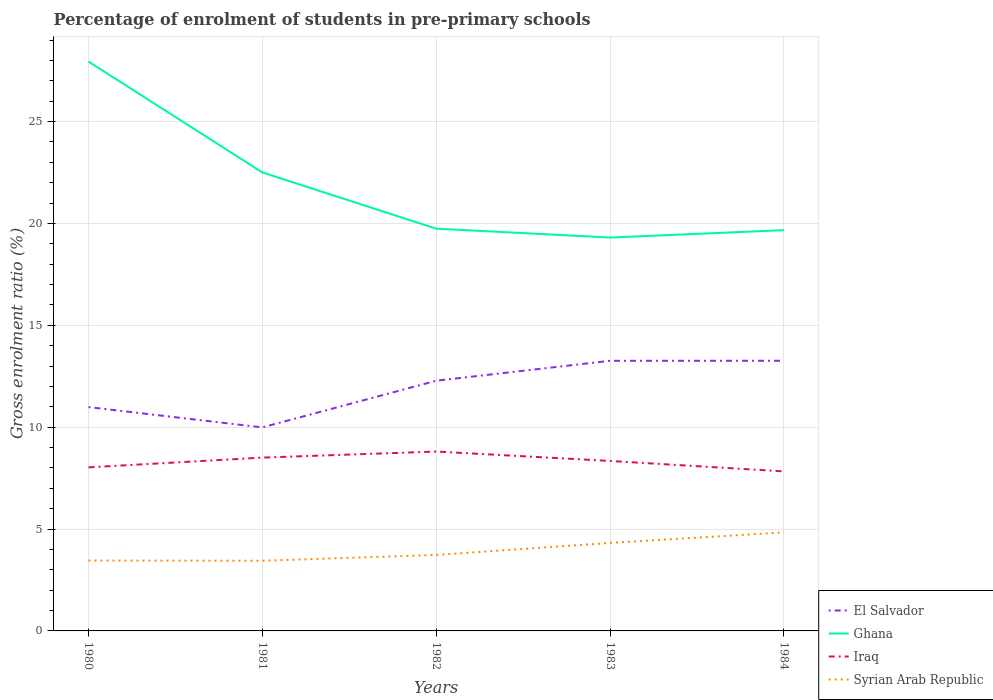How many different coloured lines are there?
Your answer should be very brief. 4. Across all years, what is the maximum percentage of students enrolled in pre-primary schools in Syrian Arab Republic?
Offer a very short reply. 3.44. What is the total percentage of students enrolled in pre-primary schools in Ghana in the graph?
Offer a very short reply. 2.76. What is the difference between the highest and the second highest percentage of students enrolled in pre-primary schools in Iraq?
Offer a very short reply. 0.97. What is the difference between the highest and the lowest percentage of students enrolled in pre-primary schools in Ghana?
Your answer should be very brief. 2. How many lines are there?
Your answer should be very brief. 4. How many years are there in the graph?
Your answer should be compact. 5. What is the difference between two consecutive major ticks on the Y-axis?
Keep it short and to the point. 5. Are the values on the major ticks of Y-axis written in scientific E-notation?
Your answer should be very brief. No. Does the graph contain any zero values?
Make the answer very short. No. Where does the legend appear in the graph?
Provide a succinct answer. Bottom right. How are the legend labels stacked?
Give a very brief answer. Vertical. What is the title of the graph?
Your response must be concise. Percentage of enrolment of students in pre-primary schools. Does "Serbia" appear as one of the legend labels in the graph?
Make the answer very short. No. What is the label or title of the X-axis?
Make the answer very short. Years. What is the Gross enrolment ratio (%) in El Salvador in 1980?
Provide a short and direct response. 10.99. What is the Gross enrolment ratio (%) of Ghana in 1980?
Provide a succinct answer. 27.94. What is the Gross enrolment ratio (%) of Iraq in 1980?
Your answer should be very brief. 8.03. What is the Gross enrolment ratio (%) in Syrian Arab Republic in 1980?
Make the answer very short. 3.45. What is the Gross enrolment ratio (%) in El Salvador in 1981?
Your answer should be compact. 9.99. What is the Gross enrolment ratio (%) of Ghana in 1981?
Give a very brief answer. 22.5. What is the Gross enrolment ratio (%) in Iraq in 1981?
Ensure brevity in your answer.  8.51. What is the Gross enrolment ratio (%) in Syrian Arab Republic in 1981?
Offer a very short reply. 3.44. What is the Gross enrolment ratio (%) of El Salvador in 1982?
Ensure brevity in your answer.  12.28. What is the Gross enrolment ratio (%) in Ghana in 1982?
Your answer should be compact. 19.74. What is the Gross enrolment ratio (%) in Iraq in 1982?
Offer a terse response. 8.8. What is the Gross enrolment ratio (%) of Syrian Arab Republic in 1982?
Your response must be concise. 3.73. What is the Gross enrolment ratio (%) of El Salvador in 1983?
Offer a terse response. 13.26. What is the Gross enrolment ratio (%) in Ghana in 1983?
Offer a very short reply. 19.31. What is the Gross enrolment ratio (%) of Iraq in 1983?
Make the answer very short. 8.34. What is the Gross enrolment ratio (%) of Syrian Arab Republic in 1983?
Your response must be concise. 4.32. What is the Gross enrolment ratio (%) of El Salvador in 1984?
Give a very brief answer. 13.26. What is the Gross enrolment ratio (%) of Ghana in 1984?
Provide a short and direct response. 19.67. What is the Gross enrolment ratio (%) in Iraq in 1984?
Make the answer very short. 7.83. What is the Gross enrolment ratio (%) in Syrian Arab Republic in 1984?
Provide a short and direct response. 4.84. Across all years, what is the maximum Gross enrolment ratio (%) of El Salvador?
Provide a short and direct response. 13.26. Across all years, what is the maximum Gross enrolment ratio (%) of Ghana?
Provide a short and direct response. 27.94. Across all years, what is the maximum Gross enrolment ratio (%) in Iraq?
Offer a very short reply. 8.8. Across all years, what is the maximum Gross enrolment ratio (%) in Syrian Arab Republic?
Your response must be concise. 4.84. Across all years, what is the minimum Gross enrolment ratio (%) in El Salvador?
Your answer should be very brief. 9.99. Across all years, what is the minimum Gross enrolment ratio (%) in Ghana?
Ensure brevity in your answer.  19.31. Across all years, what is the minimum Gross enrolment ratio (%) of Iraq?
Give a very brief answer. 7.83. Across all years, what is the minimum Gross enrolment ratio (%) in Syrian Arab Republic?
Your answer should be compact. 3.44. What is the total Gross enrolment ratio (%) in El Salvador in the graph?
Your answer should be compact. 59.77. What is the total Gross enrolment ratio (%) in Ghana in the graph?
Provide a succinct answer. 109.16. What is the total Gross enrolment ratio (%) in Iraq in the graph?
Your response must be concise. 41.51. What is the total Gross enrolment ratio (%) in Syrian Arab Republic in the graph?
Give a very brief answer. 19.78. What is the difference between the Gross enrolment ratio (%) in Ghana in 1980 and that in 1981?
Provide a succinct answer. 5.44. What is the difference between the Gross enrolment ratio (%) in Iraq in 1980 and that in 1981?
Give a very brief answer. -0.48. What is the difference between the Gross enrolment ratio (%) in Syrian Arab Republic in 1980 and that in 1981?
Keep it short and to the point. 0.01. What is the difference between the Gross enrolment ratio (%) of El Salvador in 1980 and that in 1982?
Provide a succinct answer. -1.29. What is the difference between the Gross enrolment ratio (%) in Ghana in 1980 and that in 1982?
Your response must be concise. 8.2. What is the difference between the Gross enrolment ratio (%) of Iraq in 1980 and that in 1982?
Your response must be concise. -0.78. What is the difference between the Gross enrolment ratio (%) in Syrian Arab Republic in 1980 and that in 1982?
Provide a short and direct response. -0.28. What is the difference between the Gross enrolment ratio (%) of El Salvador in 1980 and that in 1983?
Ensure brevity in your answer.  -2.27. What is the difference between the Gross enrolment ratio (%) in Ghana in 1980 and that in 1983?
Your answer should be very brief. 8.64. What is the difference between the Gross enrolment ratio (%) of Iraq in 1980 and that in 1983?
Offer a very short reply. -0.31. What is the difference between the Gross enrolment ratio (%) in Syrian Arab Republic in 1980 and that in 1983?
Offer a very short reply. -0.87. What is the difference between the Gross enrolment ratio (%) of El Salvador in 1980 and that in 1984?
Offer a very short reply. -2.27. What is the difference between the Gross enrolment ratio (%) of Ghana in 1980 and that in 1984?
Keep it short and to the point. 8.27. What is the difference between the Gross enrolment ratio (%) of Iraq in 1980 and that in 1984?
Your response must be concise. 0.2. What is the difference between the Gross enrolment ratio (%) in Syrian Arab Republic in 1980 and that in 1984?
Your answer should be compact. -1.38. What is the difference between the Gross enrolment ratio (%) of El Salvador in 1981 and that in 1982?
Make the answer very short. -2.29. What is the difference between the Gross enrolment ratio (%) in Ghana in 1981 and that in 1982?
Give a very brief answer. 2.76. What is the difference between the Gross enrolment ratio (%) of Iraq in 1981 and that in 1982?
Give a very brief answer. -0.3. What is the difference between the Gross enrolment ratio (%) in Syrian Arab Republic in 1981 and that in 1982?
Offer a terse response. -0.28. What is the difference between the Gross enrolment ratio (%) of El Salvador in 1981 and that in 1983?
Provide a short and direct response. -3.27. What is the difference between the Gross enrolment ratio (%) of Ghana in 1981 and that in 1983?
Your answer should be very brief. 3.2. What is the difference between the Gross enrolment ratio (%) in Iraq in 1981 and that in 1983?
Provide a succinct answer. 0.16. What is the difference between the Gross enrolment ratio (%) of Syrian Arab Republic in 1981 and that in 1983?
Offer a terse response. -0.88. What is the difference between the Gross enrolment ratio (%) in El Salvador in 1981 and that in 1984?
Ensure brevity in your answer.  -3.27. What is the difference between the Gross enrolment ratio (%) of Ghana in 1981 and that in 1984?
Keep it short and to the point. 2.83. What is the difference between the Gross enrolment ratio (%) in Iraq in 1981 and that in 1984?
Provide a succinct answer. 0.68. What is the difference between the Gross enrolment ratio (%) of Syrian Arab Republic in 1981 and that in 1984?
Provide a succinct answer. -1.39. What is the difference between the Gross enrolment ratio (%) in El Salvador in 1982 and that in 1983?
Give a very brief answer. -0.98. What is the difference between the Gross enrolment ratio (%) in Ghana in 1982 and that in 1983?
Ensure brevity in your answer.  0.44. What is the difference between the Gross enrolment ratio (%) in Iraq in 1982 and that in 1983?
Your answer should be compact. 0.46. What is the difference between the Gross enrolment ratio (%) of Syrian Arab Republic in 1982 and that in 1983?
Your answer should be compact. -0.59. What is the difference between the Gross enrolment ratio (%) in El Salvador in 1982 and that in 1984?
Keep it short and to the point. -0.98. What is the difference between the Gross enrolment ratio (%) of Ghana in 1982 and that in 1984?
Offer a very short reply. 0.07. What is the difference between the Gross enrolment ratio (%) of Iraq in 1982 and that in 1984?
Your response must be concise. 0.97. What is the difference between the Gross enrolment ratio (%) of Syrian Arab Republic in 1982 and that in 1984?
Give a very brief answer. -1.11. What is the difference between the Gross enrolment ratio (%) of El Salvador in 1983 and that in 1984?
Your answer should be very brief. -0. What is the difference between the Gross enrolment ratio (%) in Ghana in 1983 and that in 1984?
Your response must be concise. -0.36. What is the difference between the Gross enrolment ratio (%) in Iraq in 1983 and that in 1984?
Your response must be concise. 0.51. What is the difference between the Gross enrolment ratio (%) of Syrian Arab Republic in 1983 and that in 1984?
Ensure brevity in your answer.  -0.52. What is the difference between the Gross enrolment ratio (%) of El Salvador in 1980 and the Gross enrolment ratio (%) of Ghana in 1981?
Offer a very short reply. -11.52. What is the difference between the Gross enrolment ratio (%) of El Salvador in 1980 and the Gross enrolment ratio (%) of Iraq in 1981?
Ensure brevity in your answer.  2.48. What is the difference between the Gross enrolment ratio (%) in El Salvador in 1980 and the Gross enrolment ratio (%) in Syrian Arab Republic in 1981?
Offer a terse response. 7.54. What is the difference between the Gross enrolment ratio (%) of Ghana in 1980 and the Gross enrolment ratio (%) of Iraq in 1981?
Offer a very short reply. 19.44. What is the difference between the Gross enrolment ratio (%) of Ghana in 1980 and the Gross enrolment ratio (%) of Syrian Arab Republic in 1981?
Keep it short and to the point. 24.5. What is the difference between the Gross enrolment ratio (%) of Iraq in 1980 and the Gross enrolment ratio (%) of Syrian Arab Republic in 1981?
Offer a very short reply. 4.58. What is the difference between the Gross enrolment ratio (%) in El Salvador in 1980 and the Gross enrolment ratio (%) in Ghana in 1982?
Offer a terse response. -8.76. What is the difference between the Gross enrolment ratio (%) of El Salvador in 1980 and the Gross enrolment ratio (%) of Iraq in 1982?
Offer a very short reply. 2.18. What is the difference between the Gross enrolment ratio (%) in El Salvador in 1980 and the Gross enrolment ratio (%) in Syrian Arab Republic in 1982?
Your answer should be compact. 7.26. What is the difference between the Gross enrolment ratio (%) in Ghana in 1980 and the Gross enrolment ratio (%) in Iraq in 1982?
Your response must be concise. 19.14. What is the difference between the Gross enrolment ratio (%) of Ghana in 1980 and the Gross enrolment ratio (%) of Syrian Arab Republic in 1982?
Keep it short and to the point. 24.22. What is the difference between the Gross enrolment ratio (%) of Iraq in 1980 and the Gross enrolment ratio (%) of Syrian Arab Republic in 1982?
Give a very brief answer. 4.3. What is the difference between the Gross enrolment ratio (%) in El Salvador in 1980 and the Gross enrolment ratio (%) in Ghana in 1983?
Your answer should be compact. -8.32. What is the difference between the Gross enrolment ratio (%) in El Salvador in 1980 and the Gross enrolment ratio (%) in Iraq in 1983?
Make the answer very short. 2.64. What is the difference between the Gross enrolment ratio (%) of El Salvador in 1980 and the Gross enrolment ratio (%) of Syrian Arab Republic in 1983?
Your answer should be very brief. 6.67. What is the difference between the Gross enrolment ratio (%) of Ghana in 1980 and the Gross enrolment ratio (%) of Iraq in 1983?
Offer a very short reply. 19.6. What is the difference between the Gross enrolment ratio (%) of Ghana in 1980 and the Gross enrolment ratio (%) of Syrian Arab Republic in 1983?
Make the answer very short. 23.62. What is the difference between the Gross enrolment ratio (%) in Iraq in 1980 and the Gross enrolment ratio (%) in Syrian Arab Republic in 1983?
Your answer should be very brief. 3.71. What is the difference between the Gross enrolment ratio (%) of El Salvador in 1980 and the Gross enrolment ratio (%) of Ghana in 1984?
Offer a very short reply. -8.68. What is the difference between the Gross enrolment ratio (%) in El Salvador in 1980 and the Gross enrolment ratio (%) in Iraq in 1984?
Offer a terse response. 3.16. What is the difference between the Gross enrolment ratio (%) in El Salvador in 1980 and the Gross enrolment ratio (%) in Syrian Arab Republic in 1984?
Provide a succinct answer. 6.15. What is the difference between the Gross enrolment ratio (%) of Ghana in 1980 and the Gross enrolment ratio (%) of Iraq in 1984?
Offer a terse response. 20.11. What is the difference between the Gross enrolment ratio (%) in Ghana in 1980 and the Gross enrolment ratio (%) in Syrian Arab Republic in 1984?
Give a very brief answer. 23.11. What is the difference between the Gross enrolment ratio (%) of Iraq in 1980 and the Gross enrolment ratio (%) of Syrian Arab Republic in 1984?
Provide a short and direct response. 3.19. What is the difference between the Gross enrolment ratio (%) in El Salvador in 1981 and the Gross enrolment ratio (%) in Ghana in 1982?
Keep it short and to the point. -9.75. What is the difference between the Gross enrolment ratio (%) in El Salvador in 1981 and the Gross enrolment ratio (%) in Iraq in 1982?
Ensure brevity in your answer.  1.19. What is the difference between the Gross enrolment ratio (%) in El Salvador in 1981 and the Gross enrolment ratio (%) in Syrian Arab Republic in 1982?
Ensure brevity in your answer.  6.26. What is the difference between the Gross enrolment ratio (%) of Ghana in 1981 and the Gross enrolment ratio (%) of Iraq in 1982?
Your response must be concise. 13.7. What is the difference between the Gross enrolment ratio (%) in Ghana in 1981 and the Gross enrolment ratio (%) in Syrian Arab Republic in 1982?
Provide a succinct answer. 18.77. What is the difference between the Gross enrolment ratio (%) of Iraq in 1981 and the Gross enrolment ratio (%) of Syrian Arab Republic in 1982?
Give a very brief answer. 4.78. What is the difference between the Gross enrolment ratio (%) of El Salvador in 1981 and the Gross enrolment ratio (%) of Ghana in 1983?
Your answer should be very brief. -9.32. What is the difference between the Gross enrolment ratio (%) in El Salvador in 1981 and the Gross enrolment ratio (%) in Iraq in 1983?
Offer a terse response. 1.65. What is the difference between the Gross enrolment ratio (%) in El Salvador in 1981 and the Gross enrolment ratio (%) in Syrian Arab Republic in 1983?
Give a very brief answer. 5.67. What is the difference between the Gross enrolment ratio (%) in Ghana in 1981 and the Gross enrolment ratio (%) in Iraq in 1983?
Give a very brief answer. 14.16. What is the difference between the Gross enrolment ratio (%) in Ghana in 1981 and the Gross enrolment ratio (%) in Syrian Arab Republic in 1983?
Give a very brief answer. 18.18. What is the difference between the Gross enrolment ratio (%) of Iraq in 1981 and the Gross enrolment ratio (%) of Syrian Arab Republic in 1983?
Make the answer very short. 4.19. What is the difference between the Gross enrolment ratio (%) of El Salvador in 1981 and the Gross enrolment ratio (%) of Ghana in 1984?
Your answer should be very brief. -9.68. What is the difference between the Gross enrolment ratio (%) in El Salvador in 1981 and the Gross enrolment ratio (%) in Iraq in 1984?
Ensure brevity in your answer.  2.16. What is the difference between the Gross enrolment ratio (%) in El Salvador in 1981 and the Gross enrolment ratio (%) in Syrian Arab Republic in 1984?
Your answer should be very brief. 5.15. What is the difference between the Gross enrolment ratio (%) in Ghana in 1981 and the Gross enrolment ratio (%) in Iraq in 1984?
Offer a terse response. 14.67. What is the difference between the Gross enrolment ratio (%) of Ghana in 1981 and the Gross enrolment ratio (%) of Syrian Arab Republic in 1984?
Offer a very short reply. 17.67. What is the difference between the Gross enrolment ratio (%) of Iraq in 1981 and the Gross enrolment ratio (%) of Syrian Arab Republic in 1984?
Provide a short and direct response. 3.67. What is the difference between the Gross enrolment ratio (%) of El Salvador in 1982 and the Gross enrolment ratio (%) of Ghana in 1983?
Offer a terse response. -7.03. What is the difference between the Gross enrolment ratio (%) in El Salvador in 1982 and the Gross enrolment ratio (%) in Iraq in 1983?
Your answer should be very brief. 3.94. What is the difference between the Gross enrolment ratio (%) of El Salvador in 1982 and the Gross enrolment ratio (%) of Syrian Arab Republic in 1983?
Offer a terse response. 7.96. What is the difference between the Gross enrolment ratio (%) in Ghana in 1982 and the Gross enrolment ratio (%) in Iraq in 1983?
Offer a very short reply. 11.4. What is the difference between the Gross enrolment ratio (%) in Ghana in 1982 and the Gross enrolment ratio (%) in Syrian Arab Republic in 1983?
Offer a terse response. 15.42. What is the difference between the Gross enrolment ratio (%) of Iraq in 1982 and the Gross enrolment ratio (%) of Syrian Arab Republic in 1983?
Offer a very short reply. 4.48. What is the difference between the Gross enrolment ratio (%) in El Salvador in 1982 and the Gross enrolment ratio (%) in Ghana in 1984?
Your answer should be very brief. -7.39. What is the difference between the Gross enrolment ratio (%) of El Salvador in 1982 and the Gross enrolment ratio (%) of Iraq in 1984?
Offer a terse response. 4.45. What is the difference between the Gross enrolment ratio (%) of El Salvador in 1982 and the Gross enrolment ratio (%) of Syrian Arab Republic in 1984?
Provide a succinct answer. 7.44. What is the difference between the Gross enrolment ratio (%) of Ghana in 1982 and the Gross enrolment ratio (%) of Iraq in 1984?
Provide a short and direct response. 11.91. What is the difference between the Gross enrolment ratio (%) in Ghana in 1982 and the Gross enrolment ratio (%) in Syrian Arab Republic in 1984?
Offer a very short reply. 14.91. What is the difference between the Gross enrolment ratio (%) in Iraq in 1982 and the Gross enrolment ratio (%) in Syrian Arab Republic in 1984?
Keep it short and to the point. 3.97. What is the difference between the Gross enrolment ratio (%) in El Salvador in 1983 and the Gross enrolment ratio (%) in Ghana in 1984?
Your answer should be compact. -6.41. What is the difference between the Gross enrolment ratio (%) in El Salvador in 1983 and the Gross enrolment ratio (%) in Iraq in 1984?
Keep it short and to the point. 5.43. What is the difference between the Gross enrolment ratio (%) in El Salvador in 1983 and the Gross enrolment ratio (%) in Syrian Arab Republic in 1984?
Offer a terse response. 8.42. What is the difference between the Gross enrolment ratio (%) of Ghana in 1983 and the Gross enrolment ratio (%) of Iraq in 1984?
Your answer should be compact. 11.48. What is the difference between the Gross enrolment ratio (%) of Ghana in 1983 and the Gross enrolment ratio (%) of Syrian Arab Republic in 1984?
Provide a short and direct response. 14.47. What is the difference between the Gross enrolment ratio (%) of Iraq in 1983 and the Gross enrolment ratio (%) of Syrian Arab Republic in 1984?
Ensure brevity in your answer.  3.51. What is the average Gross enrolment ratio (%) of El Salvador per year?
Your response must be concise. 11.95. What is the average Gross enrolment ratio (%) in Ghana per year?
Offer a terse response. 21.83. What is the average Gross enrolment ratio (%) in Iraq per year?
Ensure brevity in your answer.  8.3. What is the average Gross enrolment ratio (%) in Syrian Arab Republic per year?
Make the answer very short. 3.96. In the year 1980, what is the difference between the Gross enrolment ratio (%) in El Salvador and Gross enrolment ratio (%) in Ghana?
Provide a short and direct response. -16.96. In the year 1980, what is the difference between the Gross enrolment ratio (%) in El Salvador and Gross enrolment ratio (%) in Iraq?
Give a very brief answer. 2.96. In the year 1980, what is the difference between the Gross enrolment ratio (%) in El Salvador and Gross enrolment ratio (%) in Syrian Arab Republic?
Your response must be concise. 7.53. In the year 1980, what is the difference between the Gross enrolment ratio (%) of Ghana and Gross enrolment ratio (%) of Iraq?
Provide a succinct answer. 19.92. In the year 1980, what is the difference between the Gross enrolment ratio (%) in Ghana and Gross enrolment ratio (%) in Syrian Arab Republic?
Offer a very short reply. 24.49. In the year 1980, what is the difference between the Gross enrolment ratio (%) in Iraq and Gross enrolment ratio (%) in Syrian Arab Republic?
Make the answer very short. 4.57. In the year 1981, what is the difference between the Gross enrolment ratio (%) of El Salvador and Gross enrolment ratio (%) of Ghana?
Offer a terse response. -12.51. In the year 1981, what is the difference between the Gross enrolment ratio (%) of El Salvador and Gross enrolment ratio (%) of Iraq?
Your answer should be very brief. 1.48. In the year 1981, what is the difference between the Gross enrolment ratio (%) in El Salvador and Gross enrolment ratio (%) in Syrian Arab Republic?
Provide a succinct answer. 6.55. In the year 1981, what is the difference between the Gross enrolment ratio (%) of Ghana and Gross enrolment ratio (%) of Iraq?
Offer a very short reply. 14. In the year 1981, what is the difference between the Gross enrolment ratio (%) of Ghana and Gross enrolment ratio (%) of Syrian Arab Republic?
Offer a very short reply. 19.06. In the year 1981, what is the difference between the Gross enrolment ratio (%) in Iraq and Gross enrolment ratio (%) in Syrian Arab Republic?
Give a very brief answer. 5.06. In the year 1982, what is the difference between the Gross enrolment ratio (%) in El Salvador and Gross enrolment ratio (%) in Ghana?
Your answer should be very brief. -7.46. In the year 1982, what is the difference between the Gross enrolment ratio (%) in El Salvador and Gross enrolment ratio (%) in Iraq?
Your answer should be compact. 3.48. In the year 1982, what is the difference between the Gross enrolment ratio (%) of El Salvador and Gross enrolment ratio (%) of Syrian Arab Republic?
Your answer should be very brief. 8.55. In the year 1982, what is the difference between the Gross enrolment ratio (%) of Ghana and Gross enrolment ratio (%) of Iraq?
Provide a short and direct response. 10.94. In the year 1982, what is the difference between the Gross enrolment ratio (%) of Ghana and Gross enrolment ratio (%) of Syrian Arab Republic?
Provide a short and direct response. 16.01. In the year 1982, what is the difference between the Gross enrolment ratio (%) of Iraq and Gross enrolment ratio (%) of Syrian Arab Republic?
Offer a terse response. 5.07. In the year 1983, what is the difference between the Gross enrolment ratio (%) of El Salvador and Gross enrolment ratio (%) of Ghana?
Provide a succinct answer. -6.05. In the year 1983, what is the difference between the Gross enrolment ratio (%) in El Salvador and Gross enrolment ratio (%) in Iraq?
Offer a very short reply. 4.92. In the year 1983, what is the difference between the Gross enrolment ratio (%) in El Salvador and Gross enrolment ratio (%) in Syrian Arab Republic?
Give a very brief answer. 8.94. In the year 1983, what is the difference between the Gross enrolment ratio (%) of Ghana and Gross enrolment ratio (%) of Iraq?
Your answer should be compact. 10.96. In the year 1983, what is the difference between the Gross enrolment ratio (%) of Ghana and Gross enrolment ratio (%) of Syrian Arab Republic?
Provide a succinct answer. 14.99. In the year 1983, what is the difference between the Gross enrolment ratio (%) of Iraq and Gross enrolment ratio (%) of Syrian Arab Republic?
Ensure brevity in your answer.  4.02. In the year 1984, what is the difference between the Gross enrolment ratio (%) of El Salvador and Gross enrolment ratio (%) of Ghana?
Give a very brief answer. -6.41. In the year 1984, what is the difference between the Gross enrolment ratio (%) of El Salvador and Gross enrolment ratio (%) of Iraq?
Keep it short and to the point. 5.43. In the year 1984, what is the difference between the Gross enrolment ratio (%) in El Salvador and Gross enrolment ratio (%) in Syrian Arab Republic?
Give a very brief answer. 8.42. In the year 1984, what is the difference between the Gross enrolment ratio (%) in Ghana and Gross enrolment ratio (%) in Iraq?
Provide a short and direct response. 11.84. In the year 1984, what is the difference between the Gross enrolment ratio (%) of Ghana and Gross enrolment ratio (%) of Syrian Arab Republic?
Provide a short and direct response. 14.83. In the year 1984, what is the difference between the Gross enrolment ratio (%) in Iraq and Gross enrolment ratio (%) in Syrian Arab Republic?
Your answer should be very brief. 2.99. What is the ratio of the Gross enrolment ratio (%) in El Salvador in 1980 to that in 1981?
Your answer should be very brief. 1.1. What is the ratio of the Gross enrolment ratio (%) in Ghana in 1980 to that in 1981?
Ensure brevity in your answer.  1.24. What is the ratio of the Gross enrolment ratio (%) of Iraq in 1980 to that in 1981?
Provide a succinct answer. 0.94. What is the ratio of the Gross enrolment ratio (%) of El Salvador in 1980 to that in 1982?
Provide a succinct answer. 0.89. What is the ratio of the Gross enrolment ratio (%) of Ghana in 1980 to that in 1982?
Your response must be concise. 1.42. What is the ratio of the Gross enrolment ratio (%) of Iraq in 1980 to that in 1982?
Give a very brief answer. 0.91. What is the ratio of the Gross enrolment ratio (%) of Syrian Arab Republic in 1980 to that in 1982?
Your answer should be compact. 0.93. What is the ratio of the Gross enrolment ratio (%) in El Salvador in 1980 to that in 1983?
Your response must be concise. 0.83. What is the ratio of the Gross enrolment ratio (%) in Ghana in 1980 to that in 1983?
Make the answer very short. 1.45. What is the ratio of the Gross enrolment ratio (%) in Iraq in 1980 to that in 1983?
Your answer should be very brief. 0.96. What is the ratio of the Gross enrolment ratio (%) in Syrian Arab Republic in 1980 to that in 1983?
Your answer should be compact. 0.8. What is the ratio of the Gross enrolment ratio (%) of El Salvador in 1980 to that in 1984?
Provide a short and direct response. 0.83. What is the ratio of the Gross enrolment ratio (%) in Ghana in 1980 to that in 1984?
Give a very brief answer. 1.42. What is the ratio of the Gross enrolment ratio (%) of Iraq in 1980 to that in 1984?
Your answer should be very brief. 1.03. What is the ratio of the Gross enrolment ratio (%) of Syrian Arab Republic in 1980 to that in 1984?
Offer a terse response. 0.71. What is the ratio of the Gross enrolment ratio (%) of El Salvador in 1981 to that in 1982?
Offer a terse response. 0.81. What is the ratio of the Gross enrolment ratio (%) of Ghana in 1981 to that in 1982?
Make the answer very short. 1.14. What is the ratio of the Gross enrolment ratio (%) of Iraq in 1981 to that in 1982?
Provide a short and direct response. 0.97. What is the ratio of the Gross enrolment ratio (%) in Syrian Arab Republic in 1981 to that in 1982?
Provide a succinct answer. 0.92. What is the ratio of the Gross enrolment ratio (%) of El Salvador in 1981 to that in 1983?
Make the answer very short. 0.75. What is the ratio of the Gross enrolment ratio (%) in Ghana in 1981 to that in 1983?
Provide a short and direct response. 1.17. What is the ratio of the Gross enrolment ratio (%) in Iraq in 1981 to that in 1983?
Ensure brevity in your answer.  1.02. What is the ratio of the Gross enrolment ratio (%) in Syrian Arab Republic in 1981 to that in 1983?
Make the answer very short. 0.8. What is the ratio of the Gross enrolment ratio (%) of El Salvador in 1981 to that in 1984?
Offer a very short reply. 0.75. What is the ratio of the Gross enrolment ratio (%) of Ghana in 1981 to that in 1984?
Keep it short and to the point. 1.14. What is the ratio of the Gross enrolment ratio (%) in Iraq in 1981 to that in 1984?
Provide a succinct answer. 1.09. What is the ratio of the Gross enrolment ratio (%) in Syrian Arab Republic in 1981 to that in 1984?
Offer a terse response. 0.71. What is the ratio of the Gross enrolment ratio (%) in El Salvador in 1982 to that in 1983?
Provide a short and direct response. 0.93. What is the ratio of the Gross enrolment ratio (%) of Ghana in 1982 to that in 1983?
Provide a succinct answer. 1.02. What is the ratio of the Gross enrolment ratio (%) in Iraq in 1982 to that in 1983?
Give a very brief answer. 1.06. What is the ratio of the Gross enrolment ratio (%) of Syrian Arab Republic in 1982 to that in 1983?
Ensure brevity in your answer.  0.86. What is the ratio of the Gross enrolment ratio (%) in El Salvador in 1982 to that in 1984?
Your response must be concise. 0.93. What is the ratio of the Gross enrolment ratio (%) in Iraq in 1982 to that in 1984?
Give a very brief answer. 1.12. What is the ratio of the Gross enrolment ratio (%) in Syrian Arab Republic in 1982 to that in 1984?
Ensure brevity in your answer.  0.77. What is the ratio of the Gross enrolment ratio (%) in El Salvador in 1983 to that in 1984?
Provide a short and direct response. 1. What is the ratio of the Gross enrolment ratio (%) in Ghana in 1983 to that in 1984?
Keep it short and to the point. 0.98. What is the ratio of the Gross enrolment ratio (%) of Iraq in 1983 to that in 1984?
Provide a succinct answer. 1.07. What is the ratio of the Gross enrolment ratio (%) of Syrian Arab Republic in 1983 to that in 1984?
Your answer should be very brief. 0.89. What is the difference between the highest and the second highest Gross enrolment ratio (%) of El Salvador?
Provide a short and direct response. 0. What is the difference between the highest and the second highest Gross enrolment ratio (%) of Ghana?
Ensure brevity in your answer.  5.44. What is the difference between the highest and the second highest Gross enrolment ratio (%) of Iraq?
Ensure brevity in your answer.  0.3. What is the difference between the highest and the second highest Gross enrolment ratio (%) of Syrian Arab Republic?
Provide a short and direct response. 0.52. What is the difference between the highest and the lowest Gross enrolment ratio (%) in El Salvador?
Your response must be concise. 3.27. What is the difference between the highest and the lowest Gross enrolment ratio (%) of Ghana?
Make the answer very short. 8.64. What is the difference between the highest and the lowest Gross enrolment ratio (%) of Iraq?
Make the answer very short. 0.97. What is the difference between the highest and the lowest Gross enrolment ratio (%) of Syrian Arab Republic?
Keep it short and to the point. 1.39. 